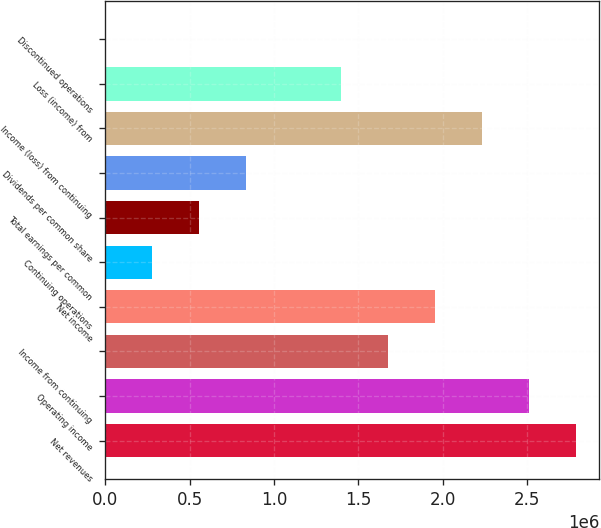Convert chart. <chart><loc_0><loc_0><loc_500><loc_500><bar_chart><fcel>Net revenues<fcel>Operating income<fcel>Income from continuing<fcel>Net income<fcel>Continuing operations<fcel>Total earnings per common<fcel>Dividends per common share<fcel>Income (loss) from continuing<fcel>Loss (income) from<fcel>Discontinued operations<nl><fcel>2.78815e+06<fcel>2.50933e+06<fcel>1.67289e+06<fcel>1.9517e+06<fcel>278815<fcel>557629<fcel>836444<fcel>2.23052e+06<fcel>1.39407e+06<fcel>0.01<nl></chart> 